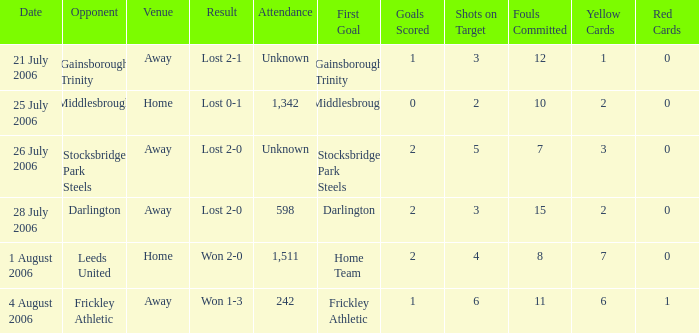Which opponent has unknown attendance, and lost 2-0? Stocksbridge Park Steels. 